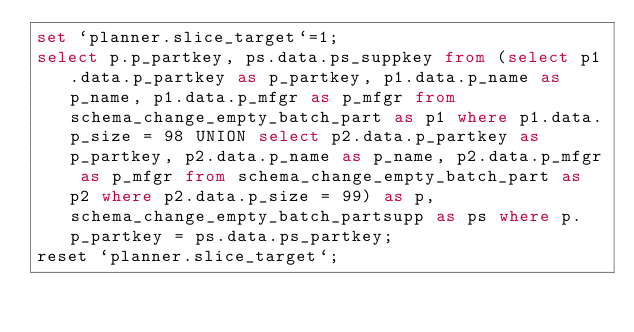<code> <loc_0><loc_0><loc_500><loc_500><_SQL_>set `planner.slice_target`=1;
select p.p_partkey, ps.data.ps_suppkey from (select p1.data.p_partkey as p_partkey, p1.data.p_name as p_name, p1.data.p_mfgr as p_mfgr from schema_change_empty_batch_part as p1 where p1.data.p_size = 98 UNION select p2.data.p_partkey as p_partkey, p2.data.p_name as p_name, p2.data.p_mfgr as p_mfgr from schema_change_empty_batch_part as p2 where p2.data.p_size = 99) as p, schema_change_empty_batch_partsupp as ps where p.p_partkey = ps.data.ps_partkey;
reset `planner.slice_target`;
</code> 